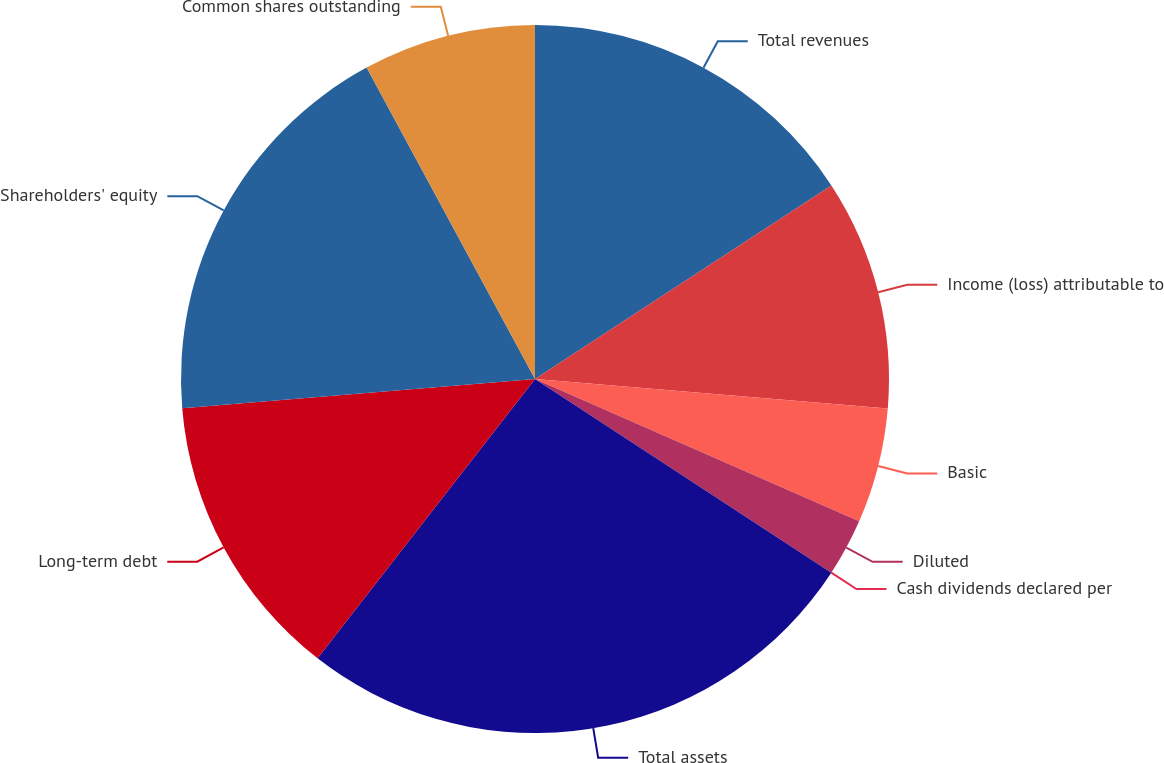Convert chart to OTSL. <chart><loc_0><loc_0><loc_500><loc_500><pie_chart><fcel>Total revenues<fcel>Income (loss) attributable to<fcel>Basic<fcel>Diluted<fcel>Cash dividends declared per<fcel>Total assets<fcel>Long-term debt<fcel>Shareholders' equity<fcel>Common shares outstanding<nl><fcel>15.79%<fcel>10.53%<fcel>5.26%<fcel>2.63%<fcel>0.0%<fcel>26.31%<fcel>13.16%<fcel>18.42%<fcel>7.89%<nl></chart> 